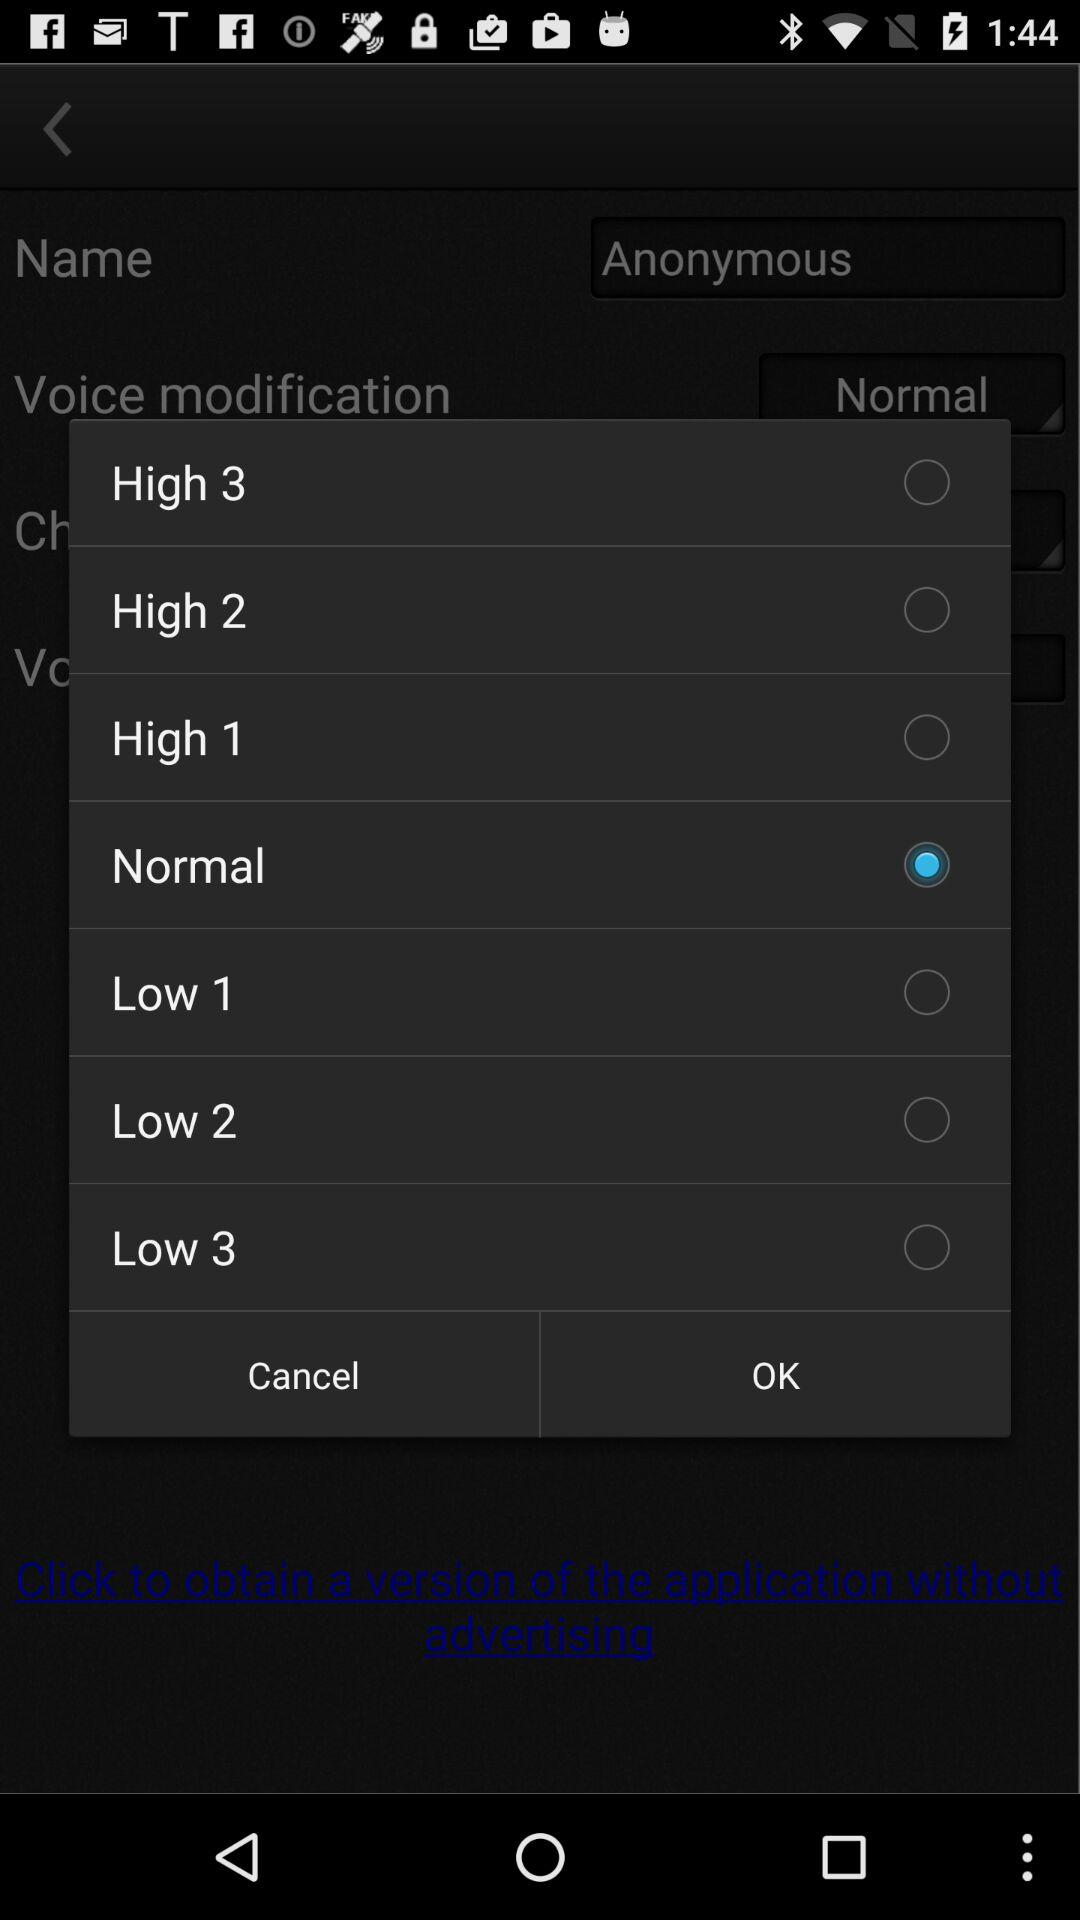What's the Lowest volume?
When the provided information is insufficient, respond with <no answer>. <no answer> 